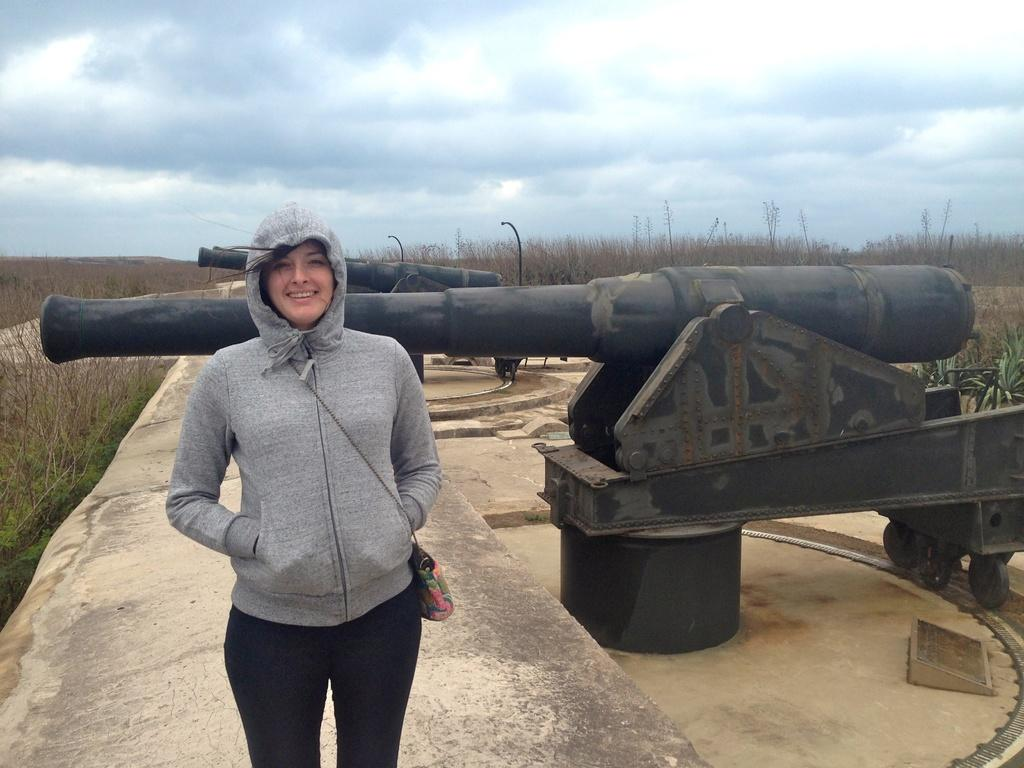Who is the main subject in the image? There is a woman in the image. Where is the woman positioned in the image? The woman is standing in the center of the image. What expression does the woman have? The woman is smiling. What can be seen in the background of the image? There are cannons and dry trees in the background of the image. What is the condition of the sky in the image? The sky is cloudy in the image. How many yaks are visible in the image? There are no yaks present in the image. What type of bee can be seen buzzing around the woman's head in the image? There are no bees visible in the image. 